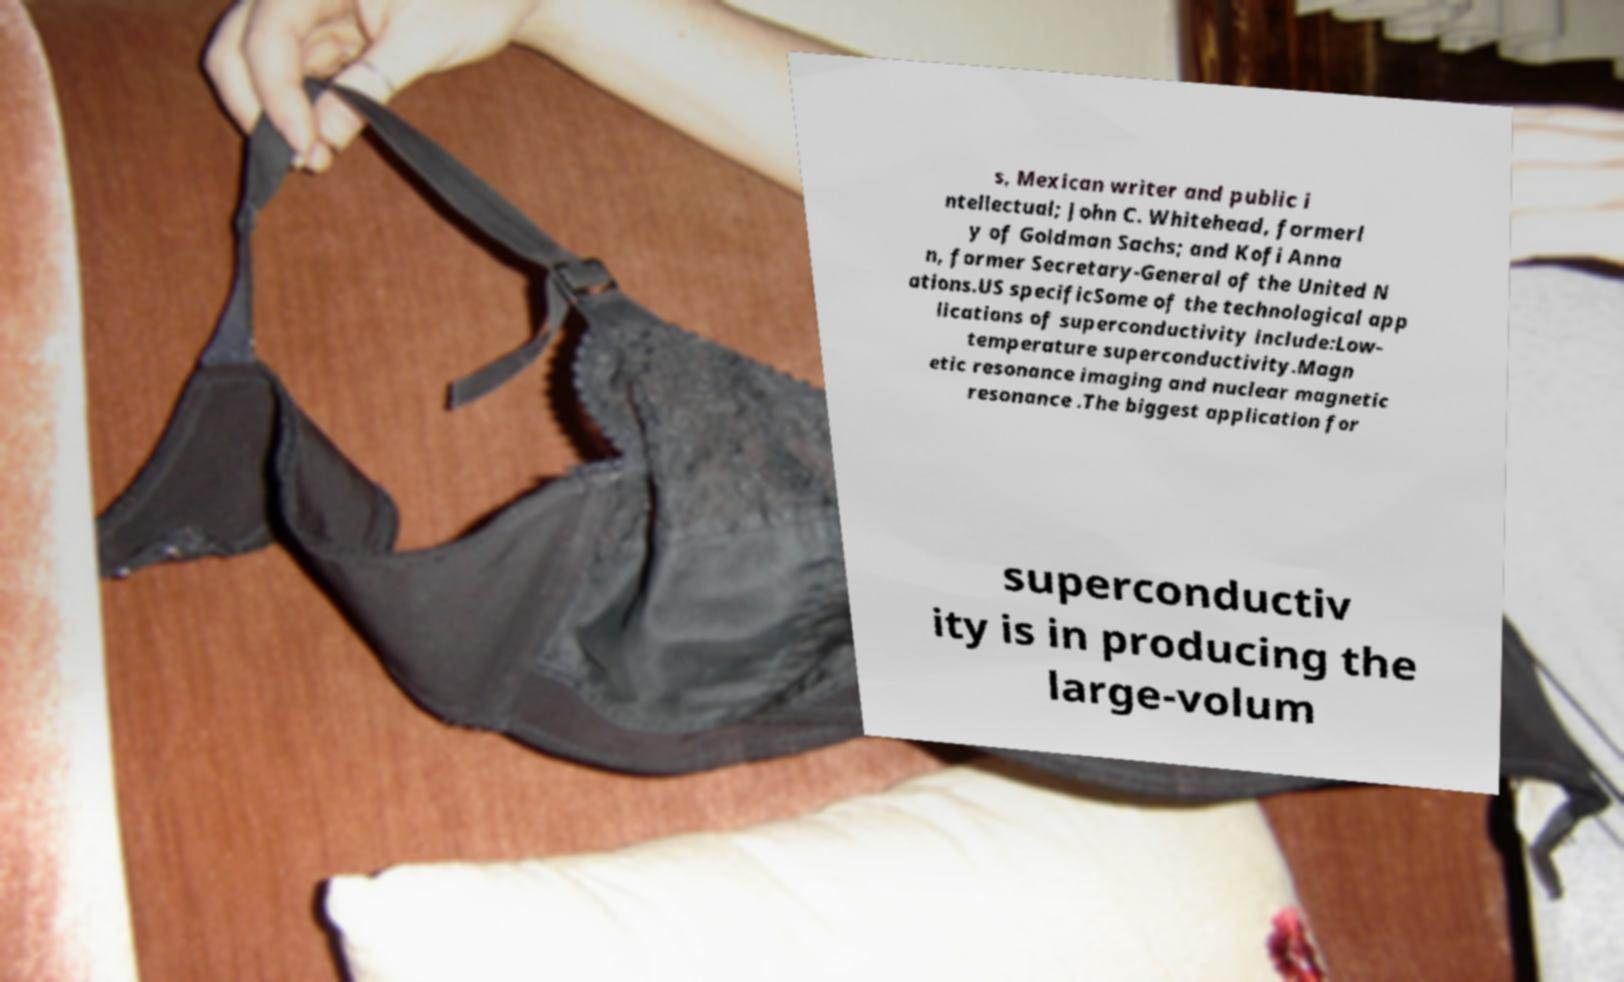What messages or text are displayed in this image? I need them in a readable, typed format. s, Mexican writer and public i ntellectual; John C. Whitehead, formerl y of Goldman Sachs; and Kofi Anna n, former Secretary-General of the United N ations.US specificSome of the technological app lications of superconductivity include:Low- temperature superconductivity.Magn etic resonance imaging and nuclear magnetic resonance .The biggest application for superconductiv ity is in producing the large-volum 